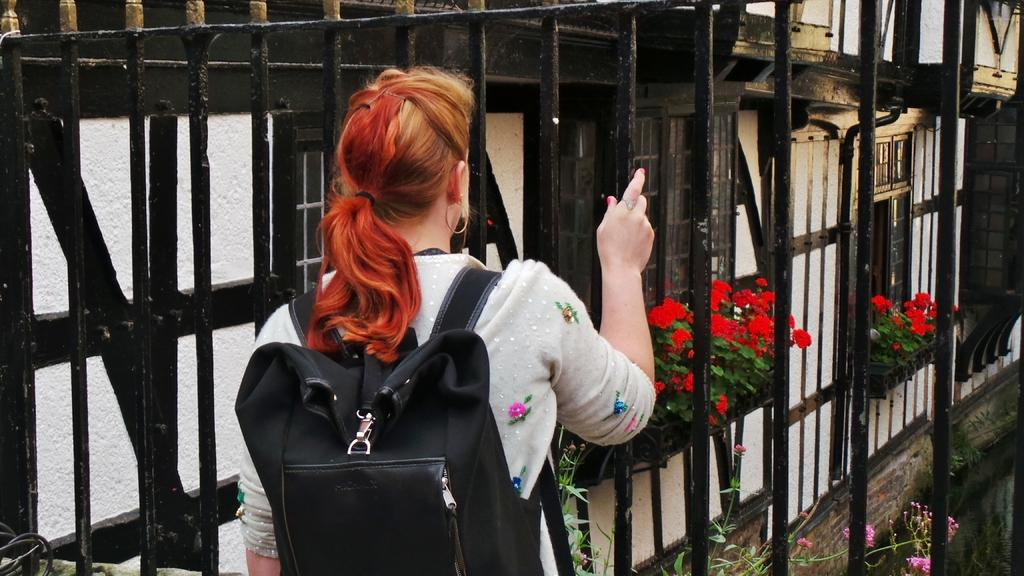Who is the main subject in the image? There is a girl standing in the image. What is the girl wearing on her back? The girl is wearing a backpack. What can be seen behind the girl in the image? There is a grille in the image. What type of vegetation is present in the image? There are plants and flowers in the image. What type of lead is the girl using to plough the field in the image? There is no lead or plough present in the image; it features a girl standing with a backpack and a grille in the background. Can you tell me how many chess pieces are on the table in the image? There is no table or chess pieces present in the image. 